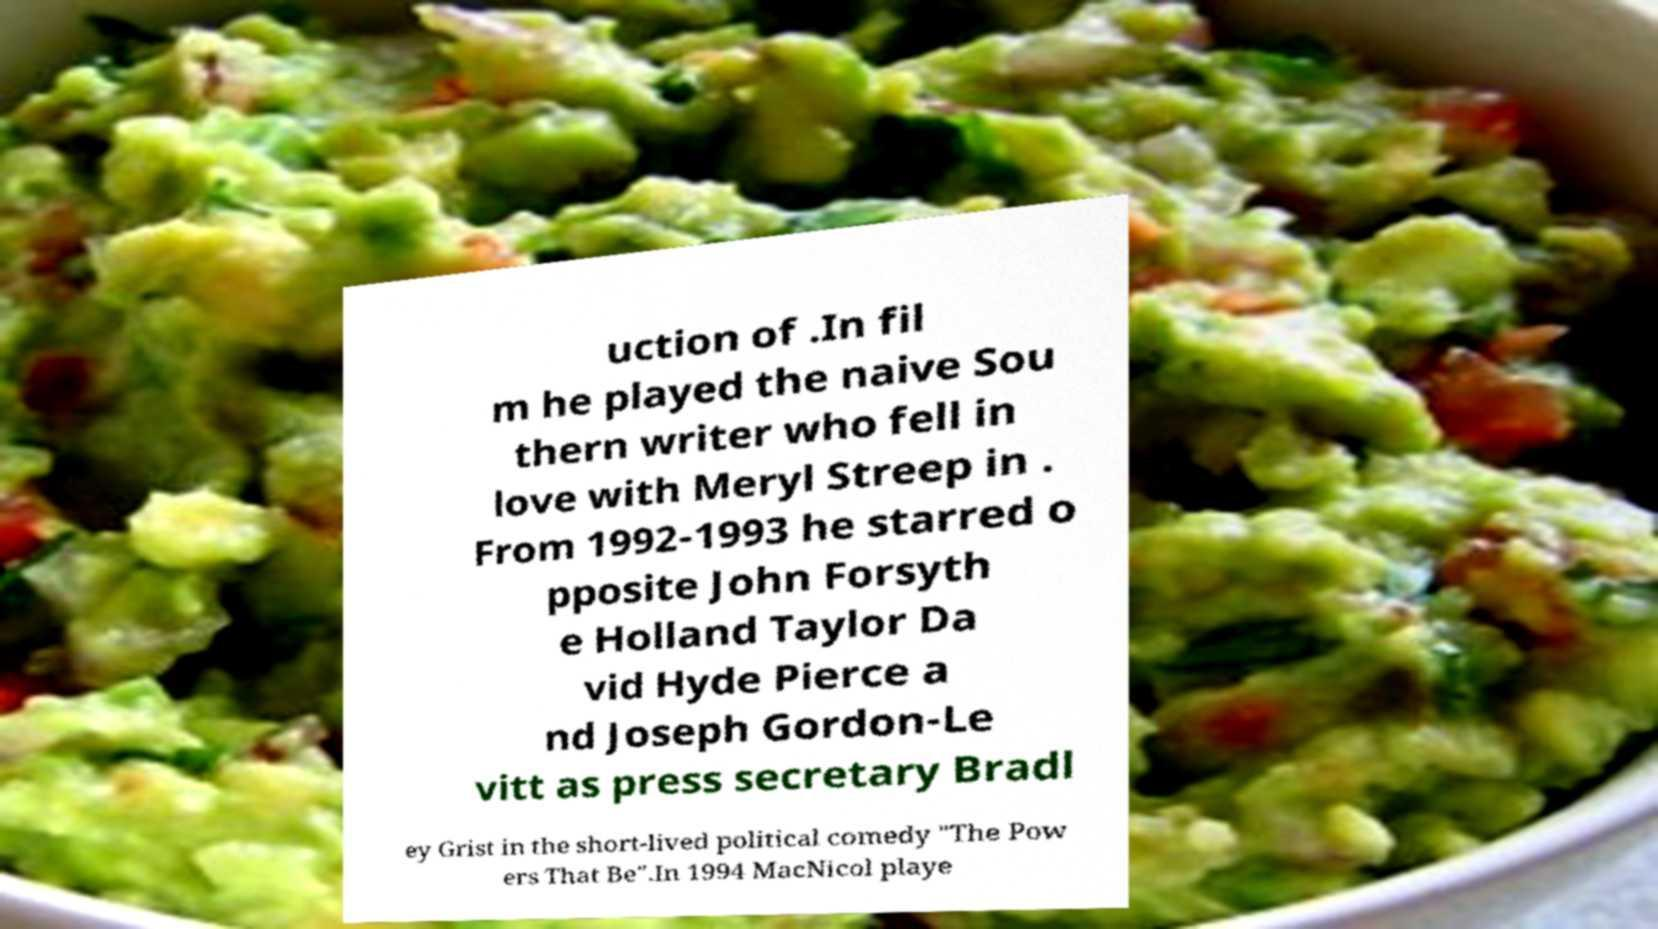Can you read and provide the text displayed in the image?This photo seems to have some interesting text. Can you extract and type it out for me? uction of .In fil m he played the naive Sou thern writer who fell in love with Meryl Streep in . From 1992-1993 he starred o pposite John Forsyth e Holland Taylor Da vid Hyde Pierce a nd Joseph Gordon-Le vitt as press secretary Bradl ey Grist in the short-lived political comedy "The Pow ers That Be".In 1994 MacNicol playe 